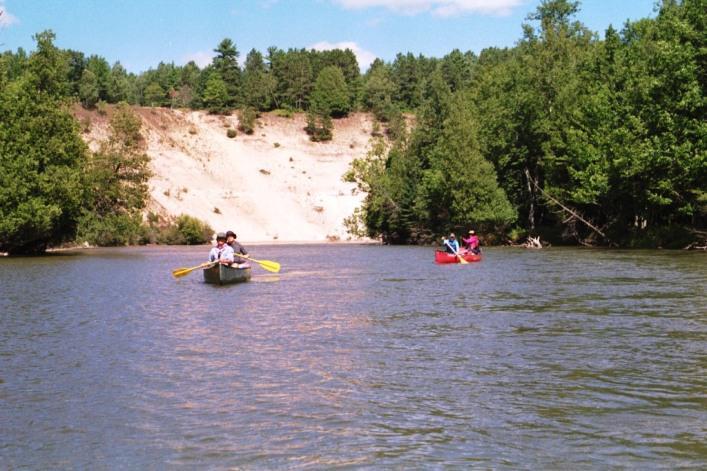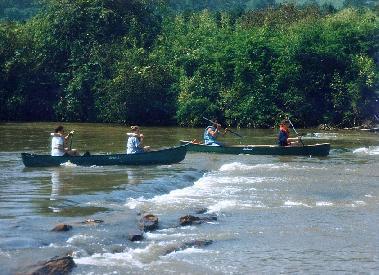The first image is the image on the left, the second image is the image on the right. Given the left and right images, does the statement "Two green canoes are parallel to each other on the water, in the right image." hold true? Answer yes or no. Yes. The first image is the image on the left, the second image is the image on the right. For the images shown, is this caption "One of the images features a single canoe." true? Answer yes or no. No. 